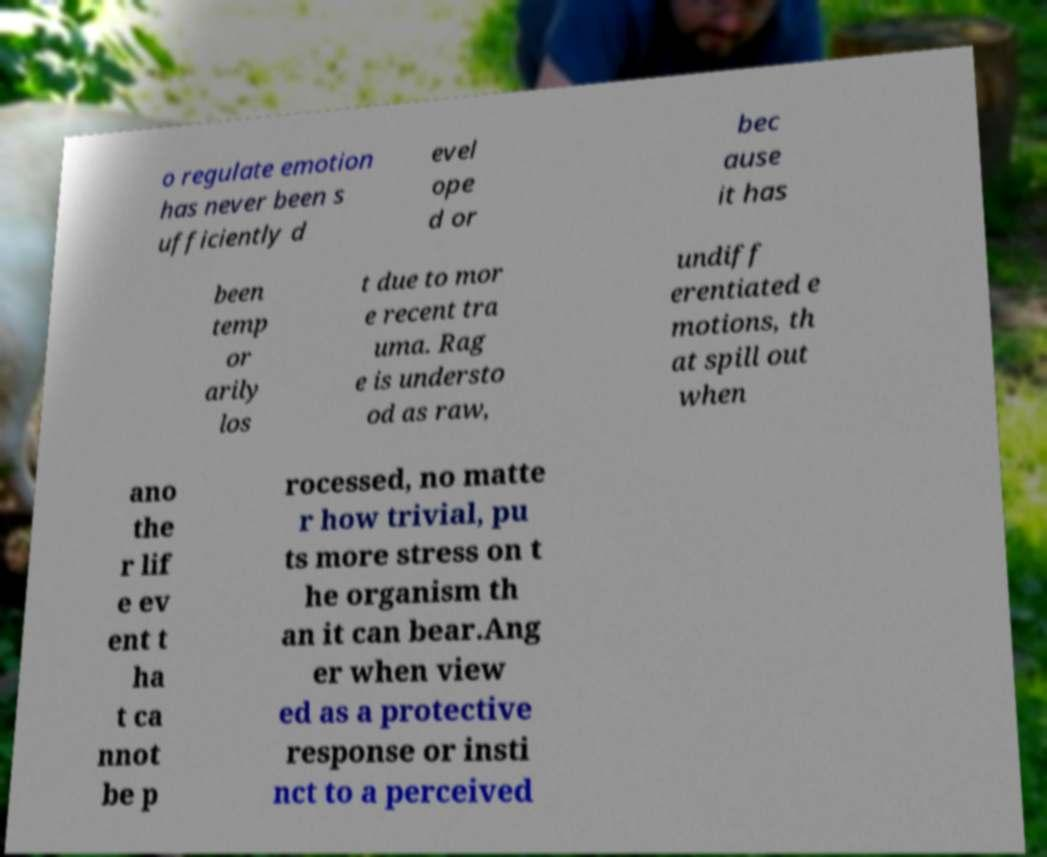Please read and relay the text visible in this image. What does it say? o regulate emotion has never been s ufficiently d evel ope d or bec ause it has been temp or arily los t due to mor e recent tra uma. Rag e is understo od as raw, undiff erentiated e motions, th at spill out when ano the r lif e ev ent t ha t ca nnot be p rocessed, no matte r how trivial, pu ts more stress on t he organism th an it can bear.Ang er when view ed as a protective response or insti nct to a perceived 